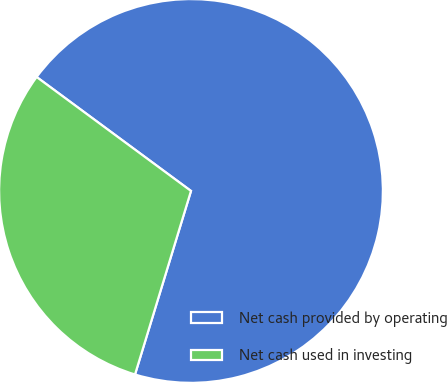Convert chart. <chart><loc_0><loc_0><loc_500><loc_500><pie_chart><fcel>Net cash provided by operating<fcel>Net cash used in investing<nl><fcel>69.59%<fcel>30.41%<nl></chart> 